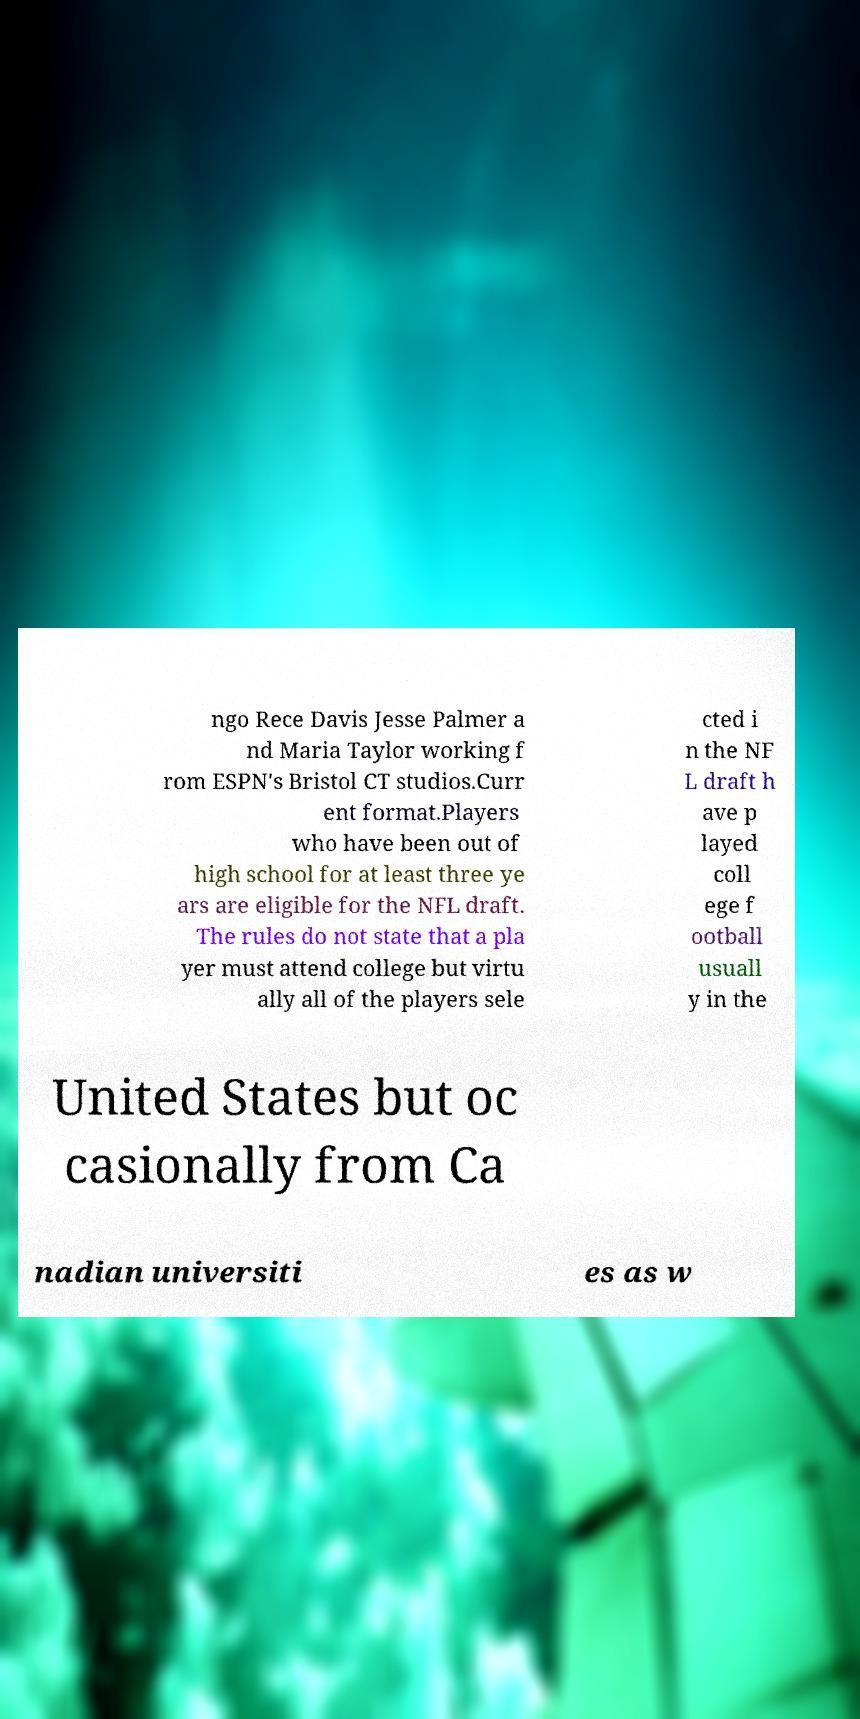I need the written content from this picture converted into text. Can you do that? ngo Rece Davis Jesse Palmer a nd Maria Taylor working f rom ESPN's Bristol CT studios.Curr ent format.Players who have been out of high school for at least three ye ars are eligible for the NFL draft. The rules do not state that a pla yer must attend college but virtu ally all of the players sele cted i n the NF L draft h ave p layed coll ege f ootball usuall y in the United States but oc casionally from Ca nadian universiti es as w 